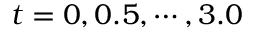<formula> <loc_0><loc_0><loc_500><loc_500>t = 0 , 0 . 5 , \cdots , 3 . 0</formula> 